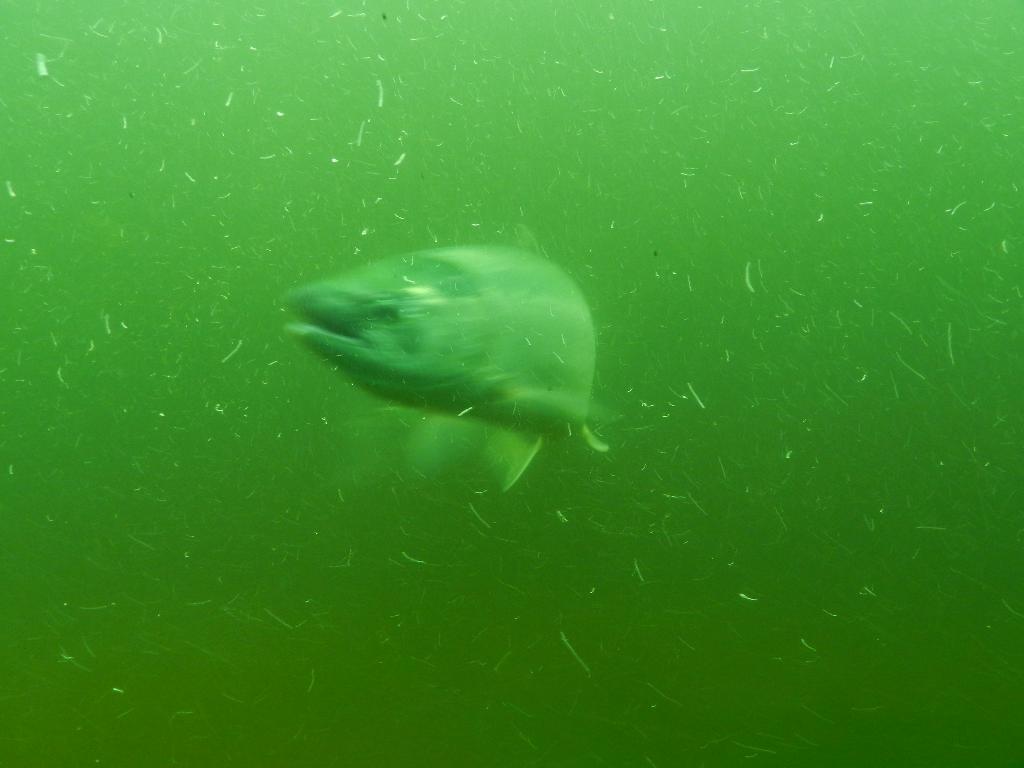Please provide a concise description of this image. In the picture we can see a fish in the water, the water is green in color. 